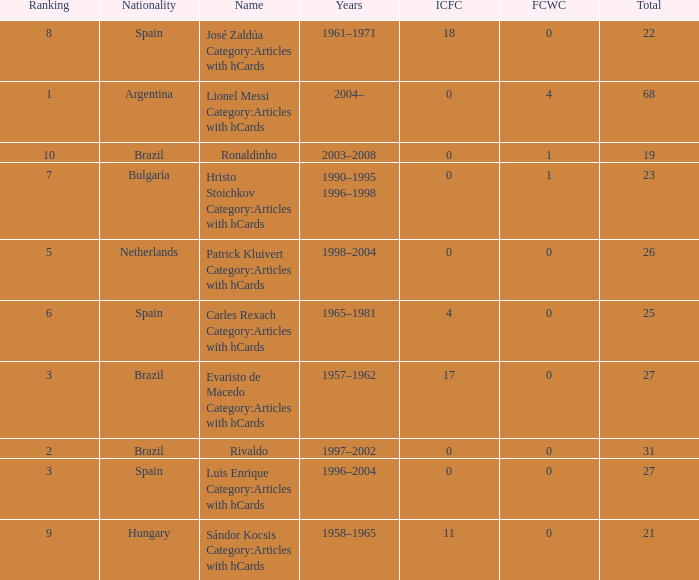What is the lowest ranking associated with a total of 23? 7.0. 